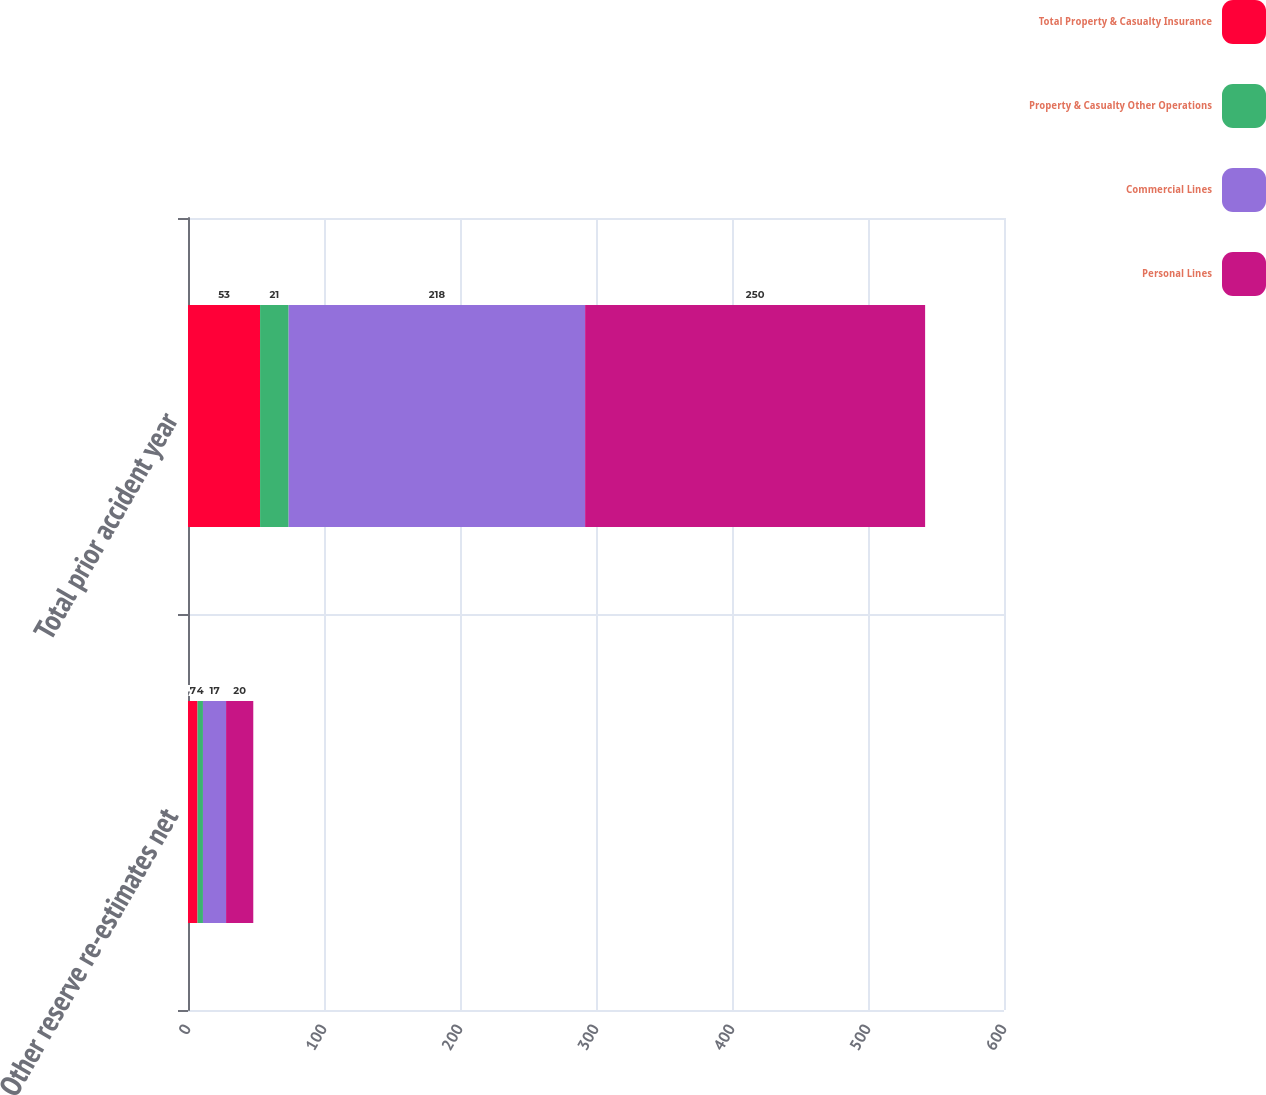<chart> <loc_0><loc_0><loc_500><loc_500><stacked_bar_chart><ecel><fcel>Other reserve re-estimates net<fcel>Total prior accident year<nl><fcel>Total Property & Casualty Insurance<fcel>7<fcel>53<nl><fcel>Property & Casualty Other Operations<fcel>4<fcel>21<nl><fcel>Commercial Lines<fcel>17<fcel>218<nl><fcel>Personal Lines<fcel>20<fcel>250<nl></chart> 